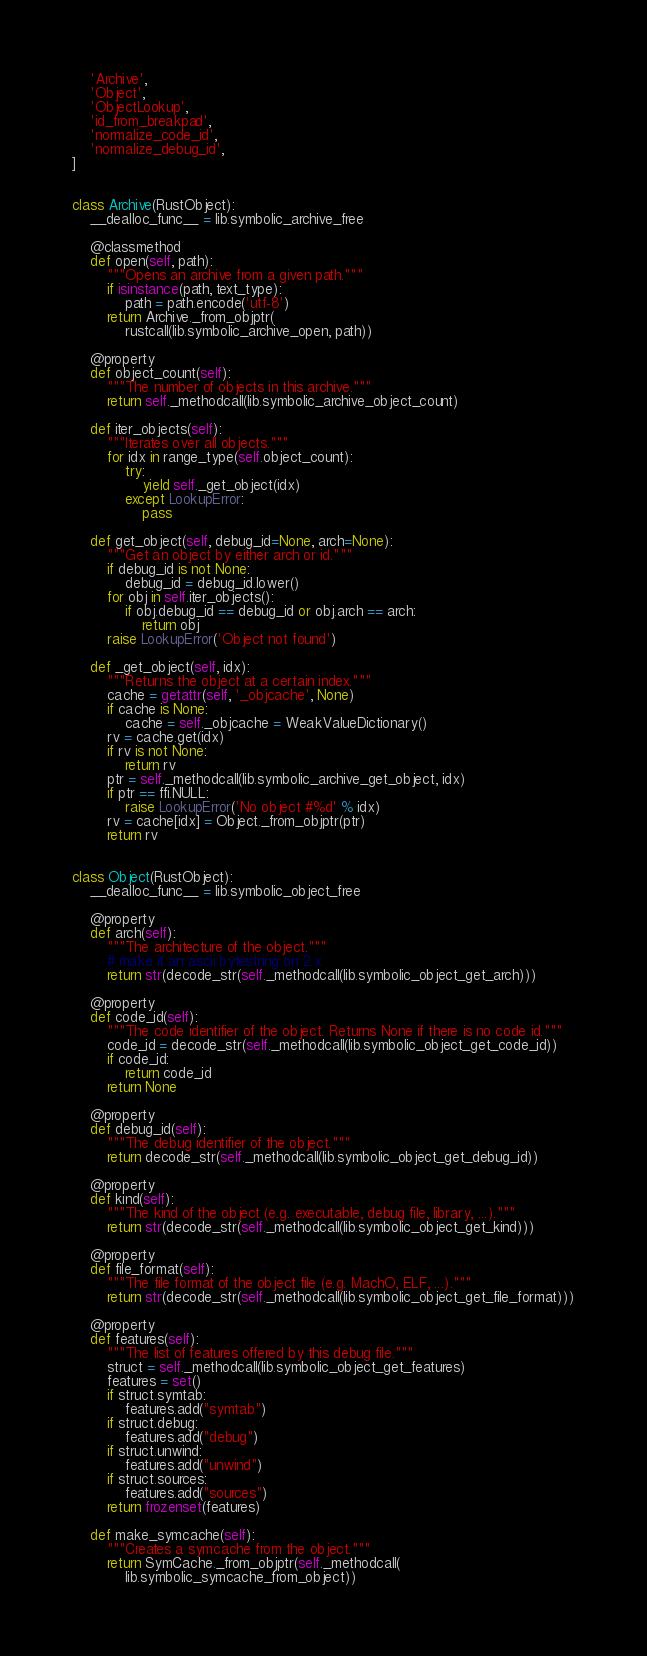Convert code to text. <code><loc_0><loc_0><loc_500><loc_500><_Python_>    'Archive',
    'Object',
    'ObjectLookup',
    'id_from_breakpad',
    'normalize_code_id',
    'normalize_debug_id',
]


class Archive(RustObject):
    __dealloc_func__ = lib.symbolic_archive_free

    @classmethod
    def open(self, path):
        """Opens an archive from a given path."""
        if isinstance(path, text_type):
            path = path.encode('utf-8')
        return Archive._from_objptr(
            rustcall(lib.symbolic_archive_open, path))

    @property
    def object_count(self):
        """The number of objects in this archive."""
        return self._methodcall(lib.symbolic_archive_object_count)

    def iter_objects(self):
        """Iterates over all objects."""
        for idx in range_type(self.object_count):
            try:
                yield self._get_object(idx)
            except LookupError:
                pass

    def get_object(self, debug_id=None, arch=None):
        """Get an object by either arch or id."""
        if debug_id is not None:
            debug_id = debug_id.lower()
        for obj in self.iter_objects():
            if obj.debug_id == debug_id or obj.arch == arch:
                return obj
        raise LookupError('Object not found')

    def _get_object(self, idx):
        """Returns the object at a certain index."""
        cache = getattr(self, '_objcache', None)
        if cache is None:
            cache = self._objcache = WeakValueDictionary()
        rv = cache.get(idx)
        if rv is not None:
            return rv
        ptr = self._methodcall(lib.symbolic_archive_get_object, idx)
        if ptr == ffi.NULL:
            raise LookupError('No object #%d' % idx)
        rv = cache[idx] = Object._from_objptr(ptr)
        return rv


class Object(RustObject):
    __dealloc_func__ = lib.symbolic_object_free

    @property
    def arch(self):
        """The architecture of the object."""
        # make it an ascii bytestring on 2.x
        return str(decode_str(self._methodcall(lib.symbolic_object_get_arch)))

    @property
    def code_id(self):
        """The code identifier of the object. Returns None if there is no code id."""
        code_id = decode_str(self._methodcall(lib.symbolic_object_get_code_id))
        if code_id:
            return code_id
        return None

    @property
    def debug_id(self):
        """The debug identifier of the object."""
        return decode_str(self._methodcall(lib.symbolic_object_get_debug_id))

    @property
    def kind(self):
        """The kind of the object (e.g. executable, debug file, library, ...)."""
        return str(decode_str(self._methodcall(lib.symbolic_object_get_kind)))

    @property
    def file_format(self):
        """The file format of the object file (e.g. MachO, ELF, ...)."""
        return str(decode_str(self._methodcall(lib.symbolic_object_get_file_format)))

    @property
    def features(self):
        """The list of features offered by this debug file."""
        struct = self._methodcall(lib.symbolic_object_get_features)
        features = set()
        if struct.symtab:
            features.add("symtab")
        if struct.debug:
            features.add("debug")
        if struct.unwind:
            features.add("unwind")
        if struct.sources:
            features.add("sources")
        return frozenset(features)

    def make_symcache(self):
        """Creates a symcache from the object."""
        return SymCache._from_objptr(self._methodcall(
            lib.symbolic_symcache_from_object))
</code> 